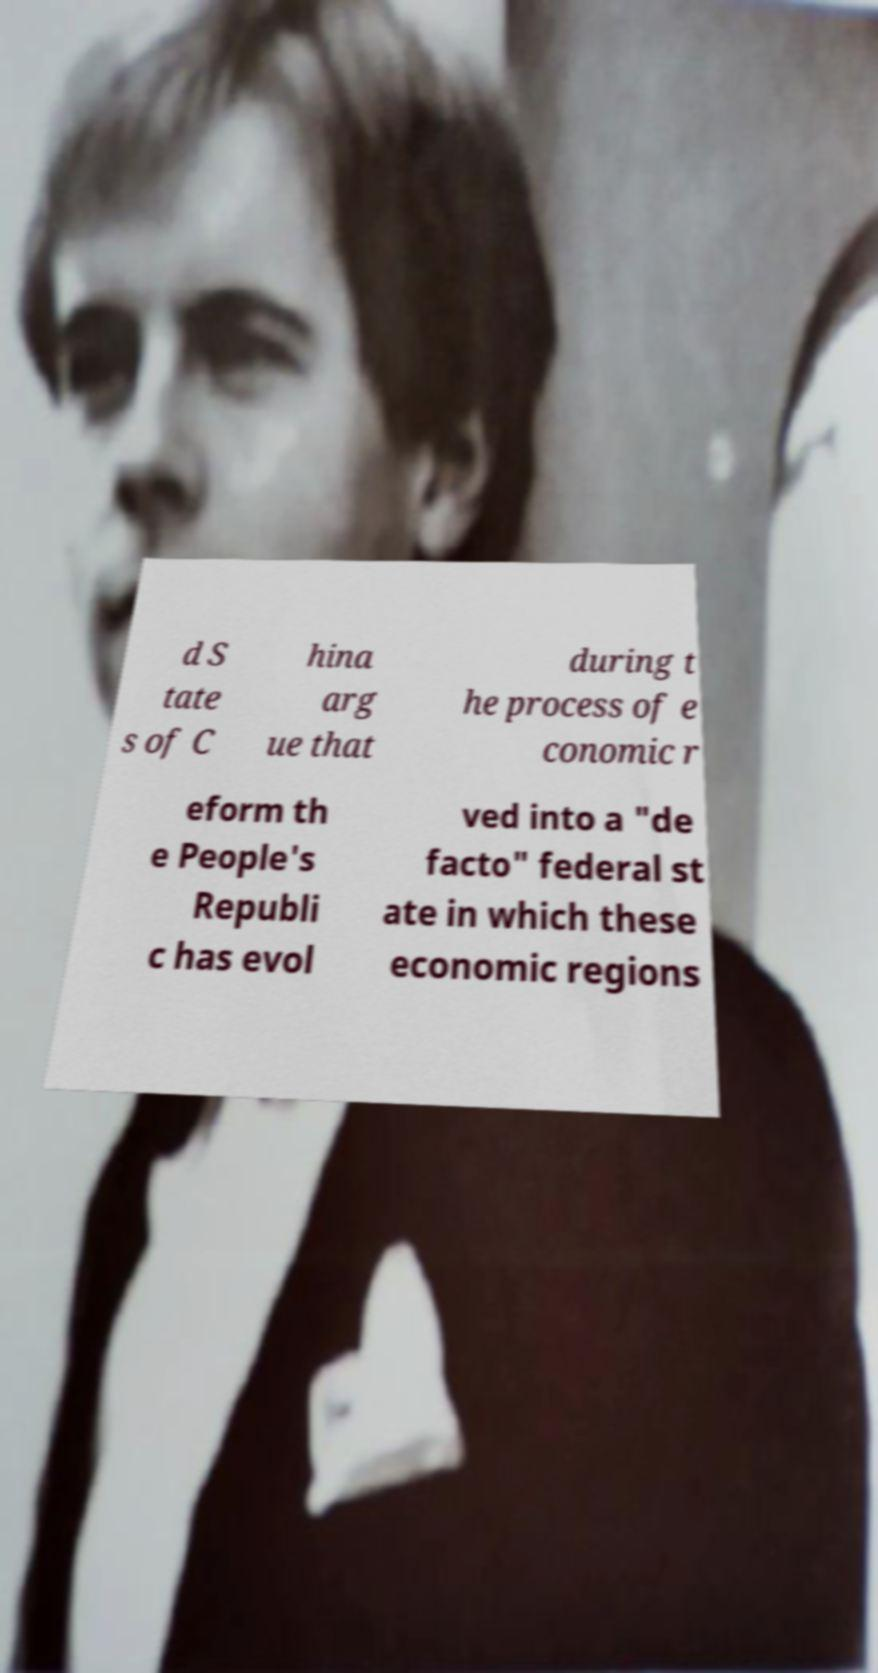Could you extract and type out the text from this image? d S tate s of C hina arg ue that during t he process of e conomic r eform th e People's Republi c has evol ved into a "de facto" federal st ate in which these economic regions 